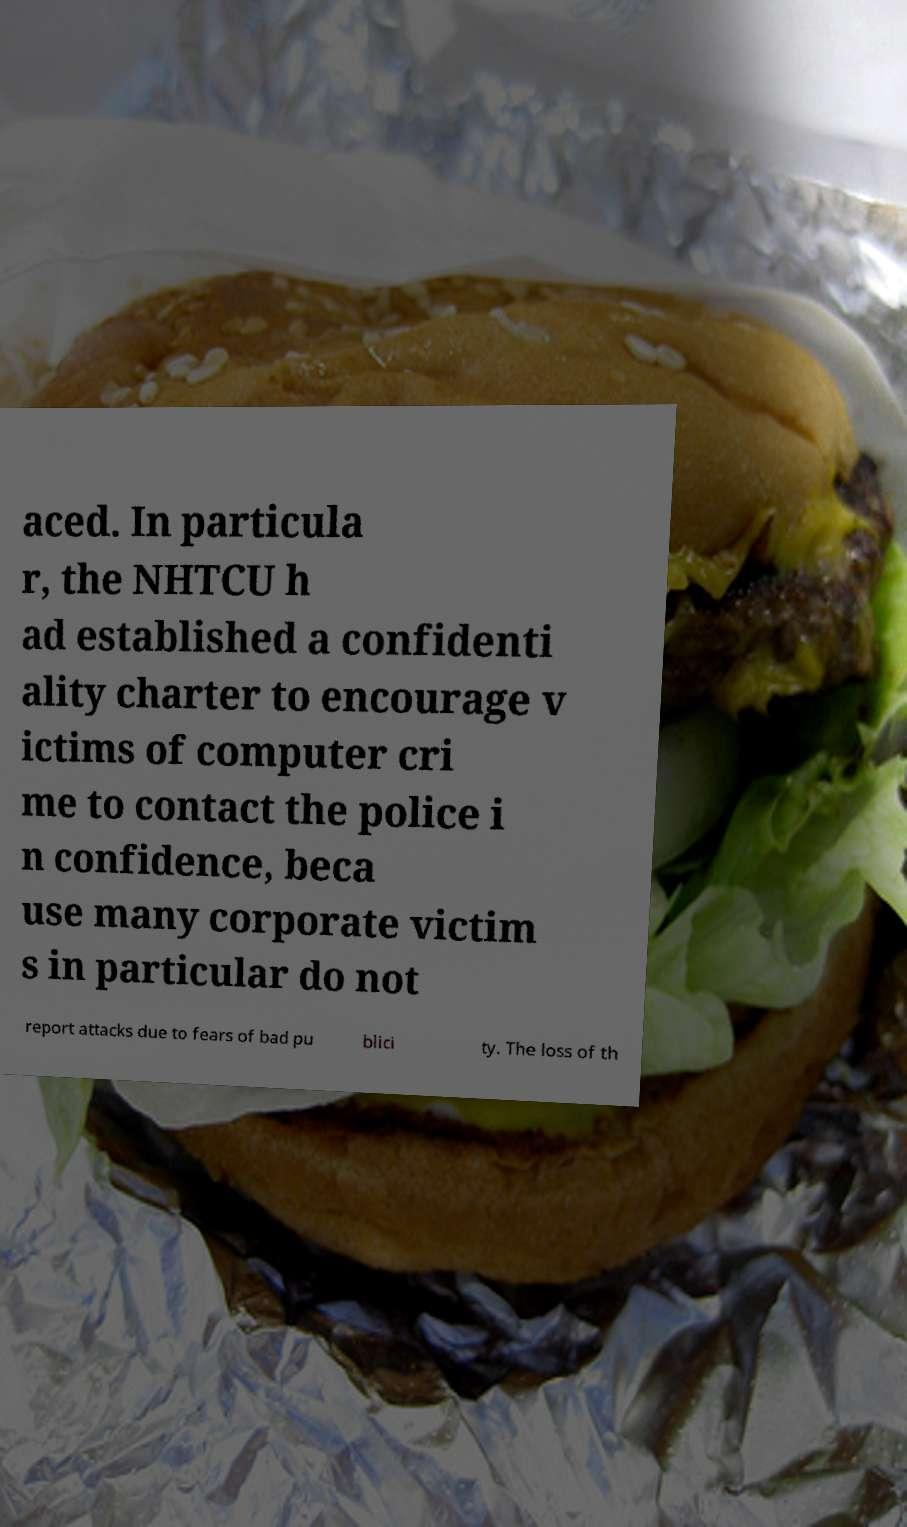For documentation purposes, I need the text within this image transcribed. Could you provide that? aced. In particula r, the NHTCU h ad established a confidenti ality charter to encourage v ictims of computer cri me to contact the police i n confidence, beca use many corporate victim s in particular do not report attacks due to fears of bad pu blici ty. The loss of th 